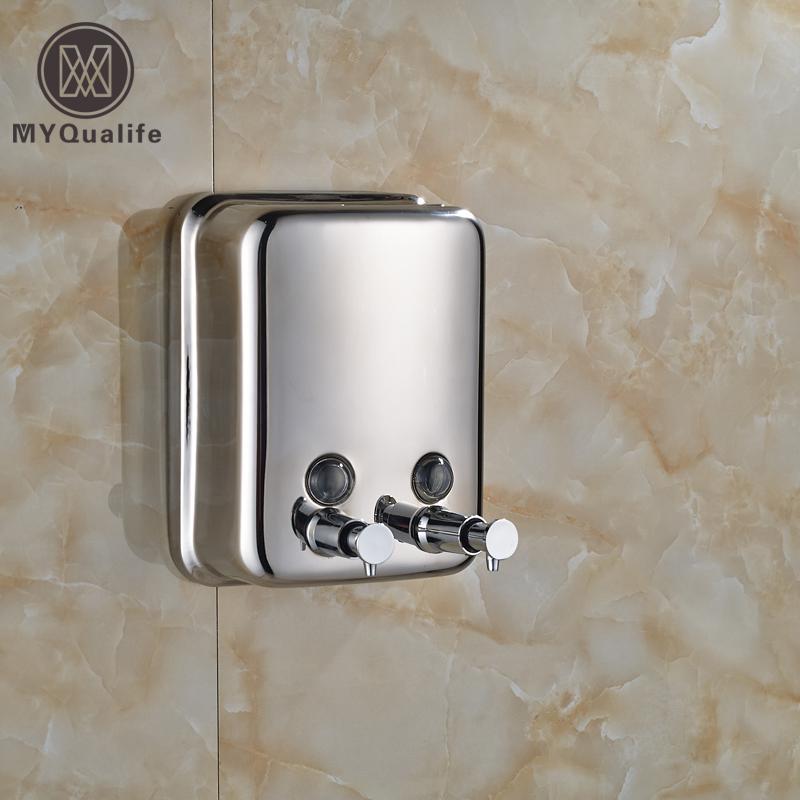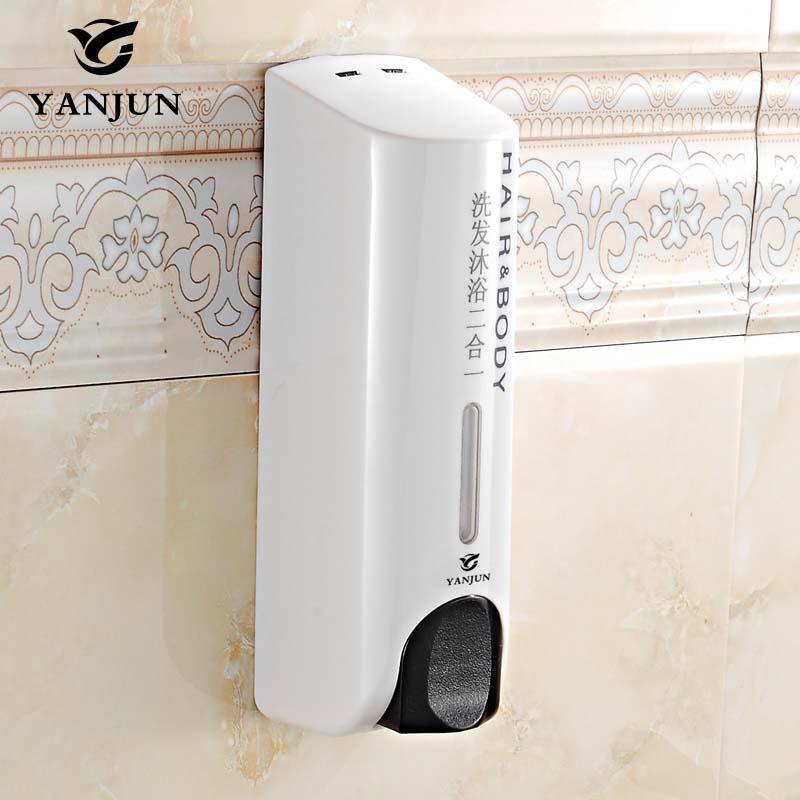The first image is the image on the left, the second image is the image on the right. Considering the images on both sides, is "In one of the images, a person's hand is visible using a soap dispenser" valid? Answer yes or no. No. The first image is the image on the left, the second image is the image on the right. For the images shown, is this caption "a human hand is dispensing soap" true? Answer yes or no. No. 